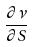<formula> <loc_0><loc_0><loc_500><loc_500>\frac { \partial \nu } { \partial S }</formula> 